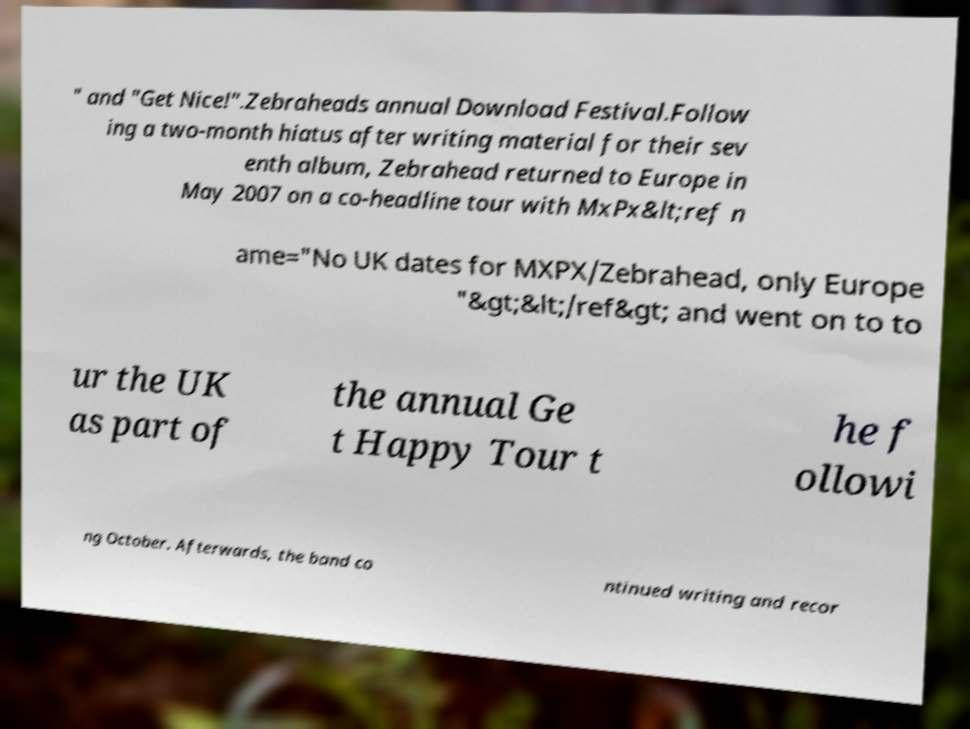Can you accurately transcribe the text from the provided image for me? " and "Get Nice!".Zebraheads annual Download Festival.Follow ing a two-month hiatus after writing material for their sev enth album, Zebrahead returned to Europe in May 2007 on a co-headline tour with MxPx&lt;ref n ame="No UK dates for MXPX/Zebrahead, only Europe "&gt;&lt;/ref&gt; and went on to to ur the UK as part of the annual Ge t Happy Tour t he f ollowi ng October. Afterwards, the band co ntinued writing and recor 